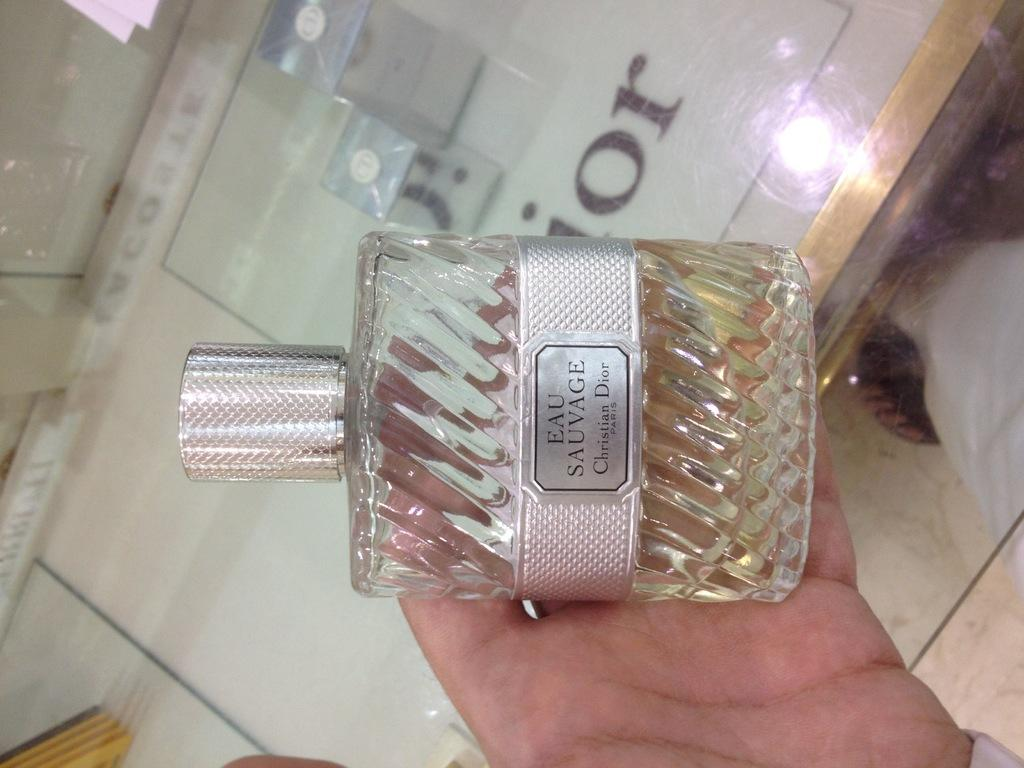<image>
Write a terse but informative summary of the picture. a hand holding a bottle of Eau Sauvage perfume 